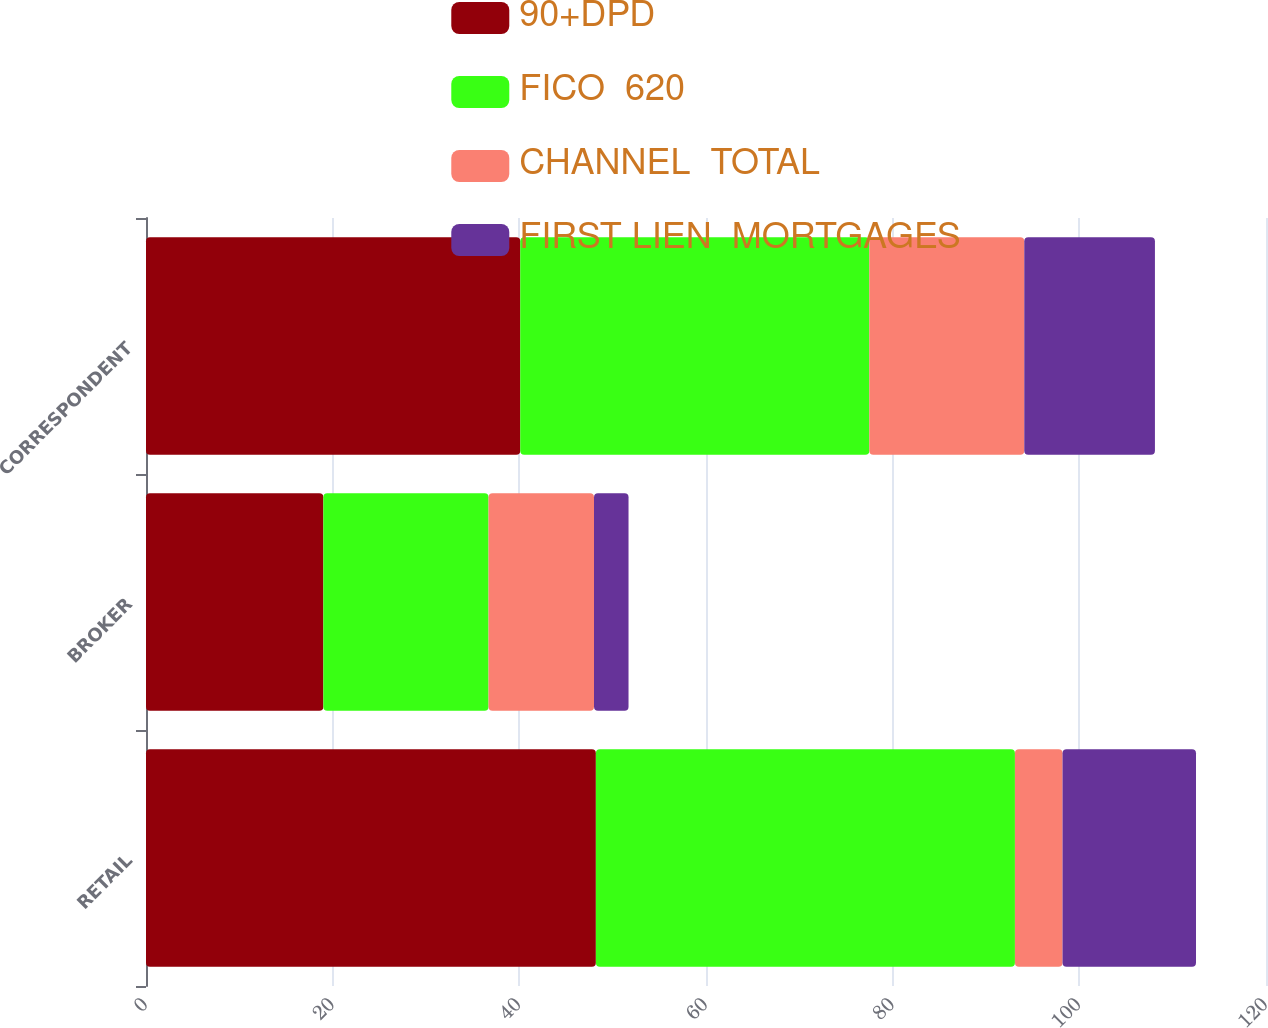Convert chart. <chart><loc_0><loc_0><loc_500><loc_500><stacked_bar_chart><ecel><fcel>RETAIL<fcel>BROKER<fcel>CORRESPONDENT<nl><fcel>90+DPD<fcel>48.2<fcel>19<fcel>40.1<nl><fcel>FICO  620<fcel>44.9<fcel>17.7<fcel>37.4<nl><fcel>CHANNEL  TOTAL<fcel>5.1<fcel>11.3<fcel>16.6<nl><fcel>FIRST LIEN  MORTGAGES<fcel>14.3<fcel>3.7<fcel>14<nl></chart> 